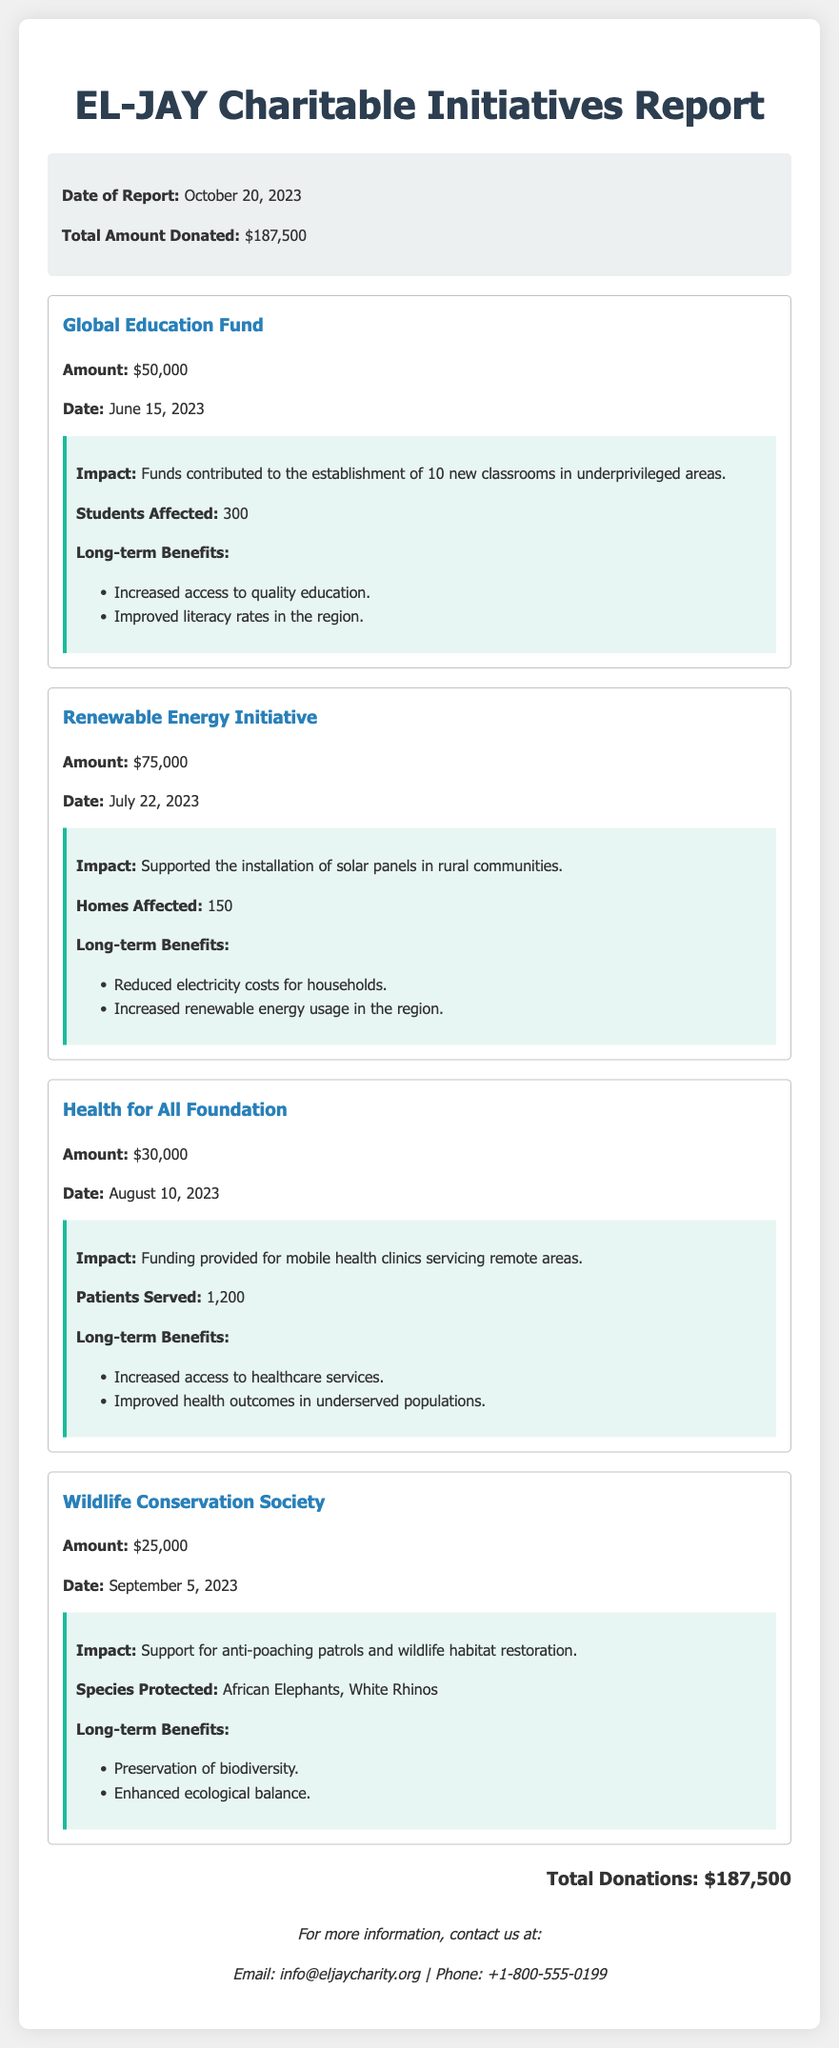What is the total amount donated? The total amount donated is summarized in the report.
Answer: $187,500 What is the date of the Global Education Fund donation? The date of this specific donation is provided in the document.
Answer: June 15, 2023 How much was donated to the Renewable Energy Initiative? The donation amount for this initiative is stated clearly in the donation section.
Answer: $75,000 How many patients were served by the Health for All Foundation? The number of patients served is mentioned in the impact details of the donation.
Answer: 1,200 What impact did the Wildlife Conservation Society support? The support provided is summarized in the impact section for this donation.
Answer: Anti-poaching patrols and wildlife habitat restoration What is the long-term benefit of the Global Education Fund donation? Long-term benefits are listed in the impact section of each donation, including this one.
Answer: Increased access to quality education How many classrooms were established by the Global Education Fund? The number of new classrooms is specified in the impact section.
Answer: 10 What was the date of the last recorded donation in the report? The last donation date is indicated in the donation details.
Answer: September 5, 2023 Which foundation received $30,000? The specific foundation that received this amount is detailed in the donation section.
Answer: Health for All Foundation 